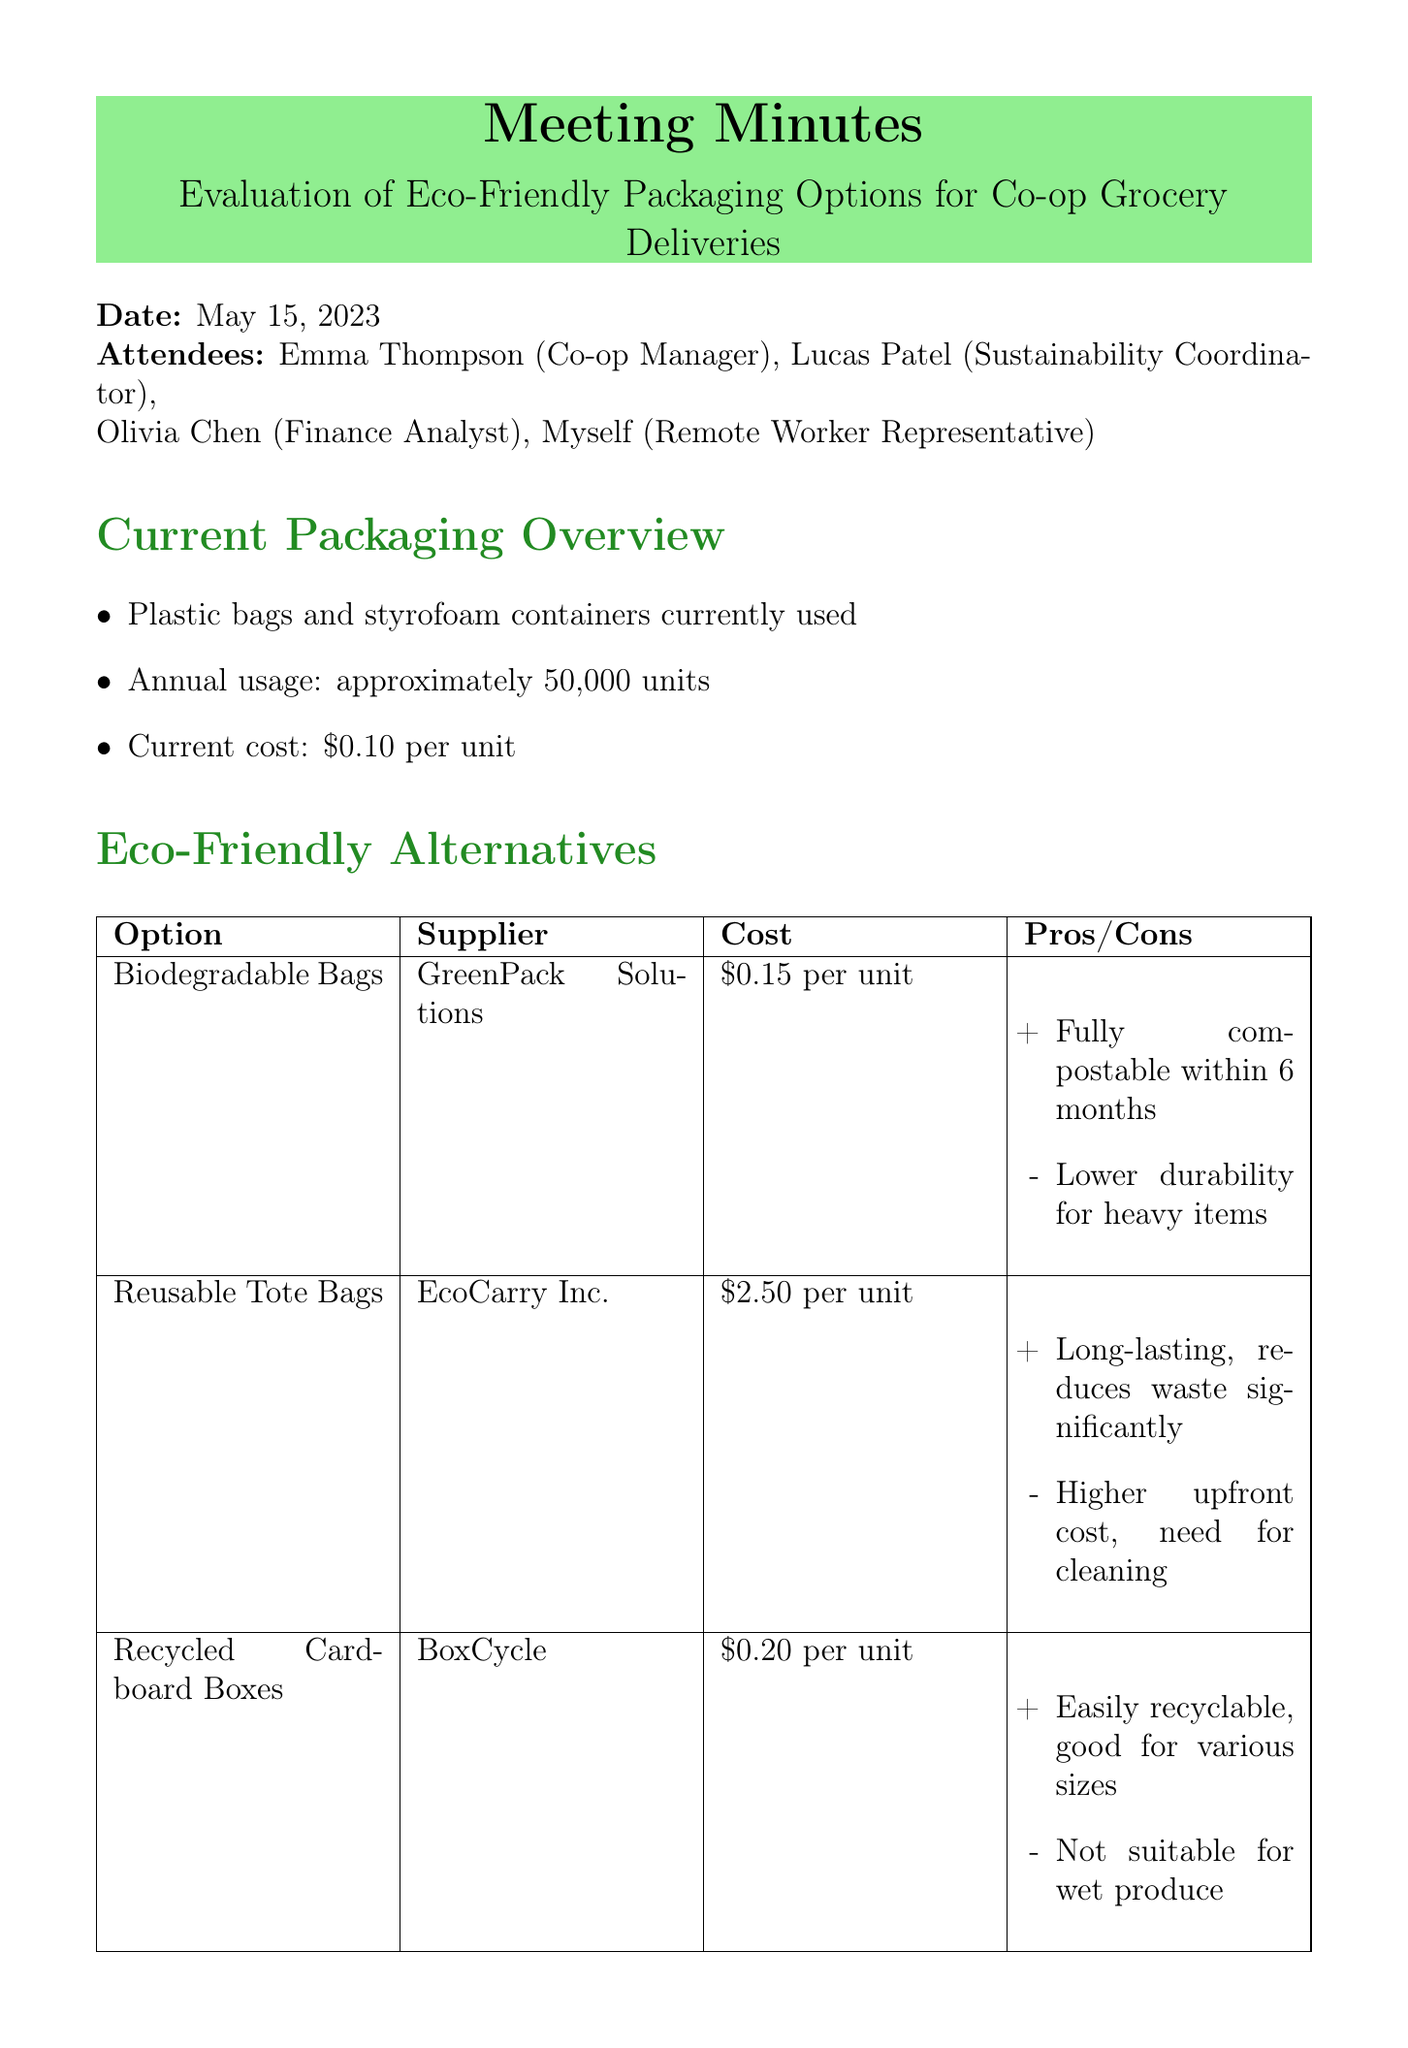What is the date of the meeting? The date of the meeting is explicitly stated in the document.
Answer: May 15, 2023 Who is the sustainability coordinator? The document lists the attendees and identifies their roles.
Answer: Lucas Patel What is the current annual cost for packaging? The document provides specific financial data regarding packaging costs.
Answer: $5,000 What percentage of customers prefer eco-friendly options? The document includes survey results that quantify customer preferences.
Answer: 75% What is one advantage of biodegradable bags? The document lists pros and cons of each eco-friendly packaging option.
Answer: Fully compostable within 6 months How much will it cost annually to use recycled cardboard boxes? The cost analysis section outlines the estimated annual costs for each option.
Answer: $10,000 What is the estimated annual cost for reusable tote bags with four uses per tote? The document presents an estimation based on the usage assumptions provided.
Answer: $31,250 What action will be taken regarding biodegradable bags? The next steps section outlines planned actions based on the discussions in the meeting.
Answer: Conduct trial run with biodegradable bags for one month What company supplies recycled cardboard boxes? The eco-friendly alternatives section specifies the supplier for each option.
Answer: BoxCycle 